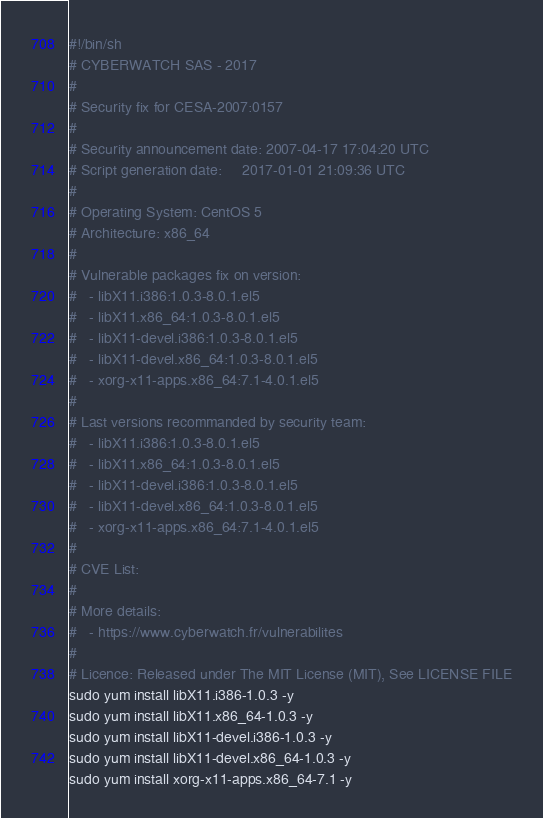<code> <loc_0><loc_0><loc_500><loc_500><_Bash_>#!/bin/sh
# CYBERWATCH SAS - 2017
#
# Security fix for CESA-2007:0157
#
# Security announcement date: 2007-04-17 17:04:20 UTC
# Script generation date:     2017-01-01 21:09:36 UTC
#
# Operating System: CentOS 5
# Architecture: x86_64
#
# Vulnerable packages fix on version:
#   - libX11.i386:1.0.3-8.0.1.el5
#   - libX11.x86_64:1.0.3-8.0.1.el5
#   - libX11-devel.i386:1.0.3-8.0.1.el5
#   - libX11-devel.x86_64:1.0.3-8.0.1.el5
#   - xorg-x11-apps.x86_64:7.1-4.0.1.el5
#
# Last versions recommanded by security team:
#   - libX11.i386:1.0.3-8.0.1.el5
#   - libX11.x86_64:1.0.3-8.0.1.el5
#   - libX11-devel.i386:1.0.3-8.0.1.el5
#   - libX11-devel.x86_64:1.0.3-8.0.1.el5
#   - xorg-x11-apps.x86_64:7.1-4.0.1.el5
#
# CVE List:
#
# More details:
#   - https://www.cyberwatch.fr/vulnerabilites
#
# Licence: Released under The MIT License (MIT), See LICENSE FILE
sudo yum install libX11.i386-1.0.3 -y 
sudo yum install libX11.x86_64-1.0.3 -y 
sudo yum install libX11-devel.i386-1.0.3 -y 
sudo yum install libX11-devel.x86_64-1.0.3 -y 
sudo yum install xorg-x11-apps.x86_64-7.1 -y 
</code> 